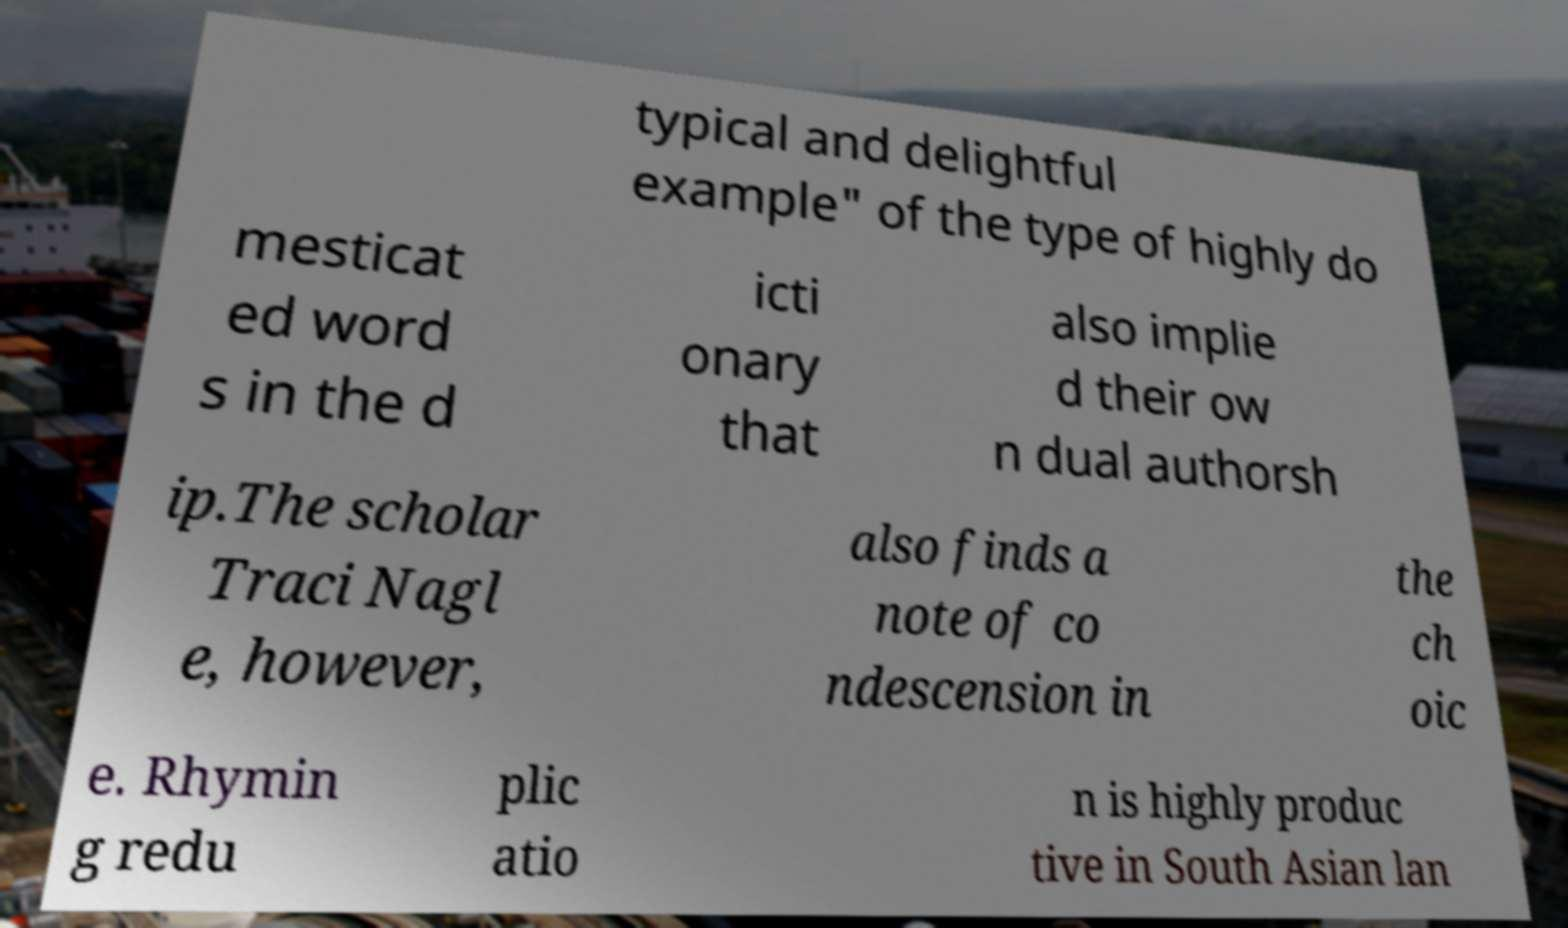Can you read and provide the text displayed in the image?This photo seems to have some interesting text. Can you extract and type it out for me? typical and delightful example" of the type of highly do mesticat ed word s in the d icti onary that also implie d their ow n dual authorsh ip.The scholar Traci Nagl e, however, also finds a note of co ndescension in the ch oic e. Rhymin g redu plic atio n is highly produc tive in South Asian lan 